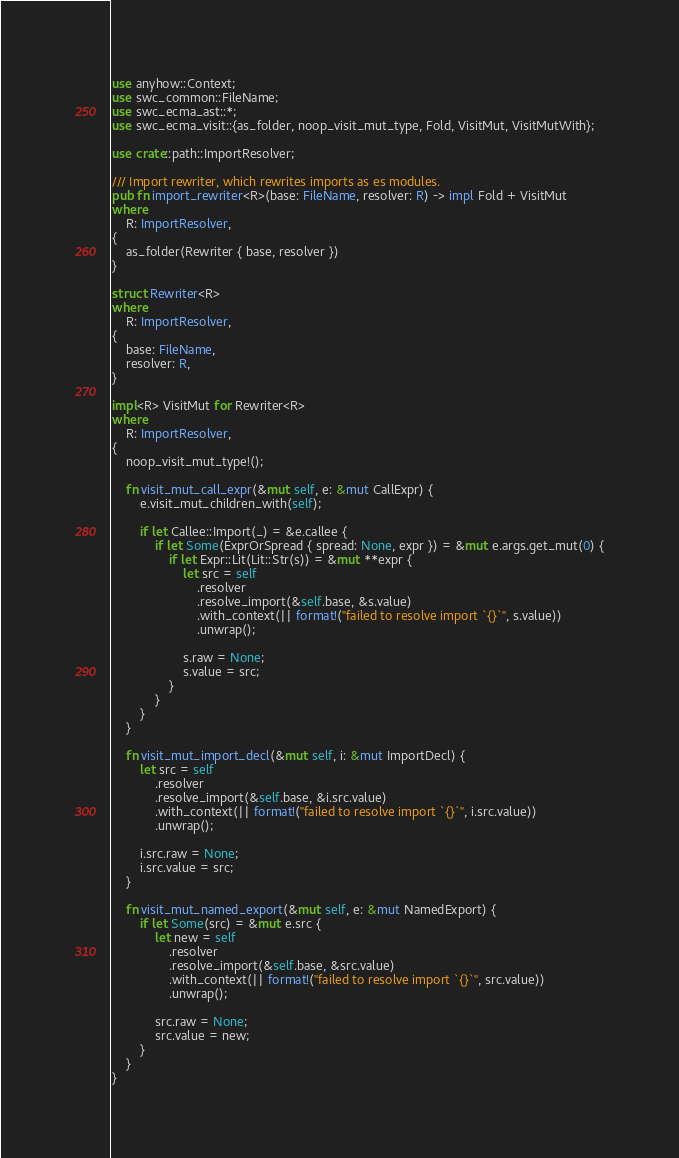<code> <loc_0><loc_0><loc_500><loc_500><_Rust_>use anyhow::Context;
use swc_common::FileName;
use swc_ecma_ast::*;
use swc_ecma_visit::{as_folder, noop_visit_mut_type, Fold, VisitMut, VisitMutWith};

use crate::path::ImportResolver;

/// Import rewriter, which rewrites imports as es modules.
pub fn import_rewriter<R>(base: FileName, resolver: R) -> impl Fold + VisitMut
where
    R: ImportResolver,
{
    as_folder(Rewriter { base, resolver })
}

struct Rewriter<R>
where
    R: ImportResolver,
{
    base: FileName,
    resolver: R,
}

impl<R> VisitMut for Rewriter<R>
where
    R: ImportResolver,
{
    noop_visit_mut_type!();

    fn visit_mut_call_expr(&mut self, e: &mut CallExpr) {
        e.visit_mut_children_with(self);

        if let Callee::Import(_) = &e.callee {
            if let Some(ExprOrSpread { spread: None, expr }) = &mut e.args.get_mut(0) {
                if let Expr::Lit(Lit::Str(s)) = &mut **expr {
                    let src = self
                        .resolver
                        .resolve_import(&self.base, &s.value)
                        .with_context(|| format!("failed to resolve import `{}`", s.value))
                        .unwrap();

                    s.raw = None;
                    s.value = src;
                }
            }
        }
    }

    fn visit_mut_import_decl(&mut self, i: &mut ImportDecl) {
        let src = self
            .resolver
            .resolve_import(&self.base, &i.src.value)
            .with_context(|| format!("failed to resolve import `{}`", i.src.value))
            .unwrap();

        i.src.raw = None;
        i.src.value = src;
    }

    fn visit_mut_named_export(&mut self, e: &mut NamedExport) {
        if let Some(src) = &mut e.src {
            let new = self
                .resolver
                .resolve_import(&self.base, &src.value)
                .with_context(|| format!("failed to resolve import `{}`", src.value))
                .unwrap();

            src.raw = None;
            src.value = new;
        }
    }
}
</code> 